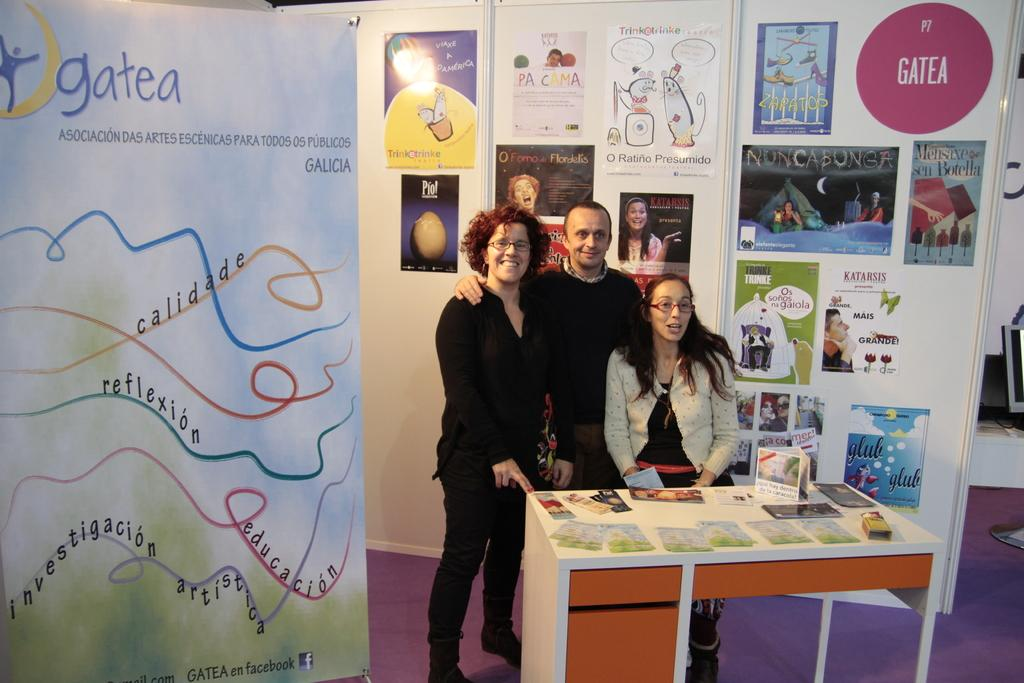What electronic device is located on the right side of the image? There is a computer on the right side of the image. What can be seen on the table in the image? There are objects on a table in the image. How many people are present in the image? There are three people in the image. What is visible on the wall in the background of the image? There are posters on the wall in the background of the image. What type of trade is being conducted in the image? There is no indication of any trade being conducted in the image. How does the motion of the people in the image affect the overall composition? The people in the image are not in motion, so their position does not affect the composition. 